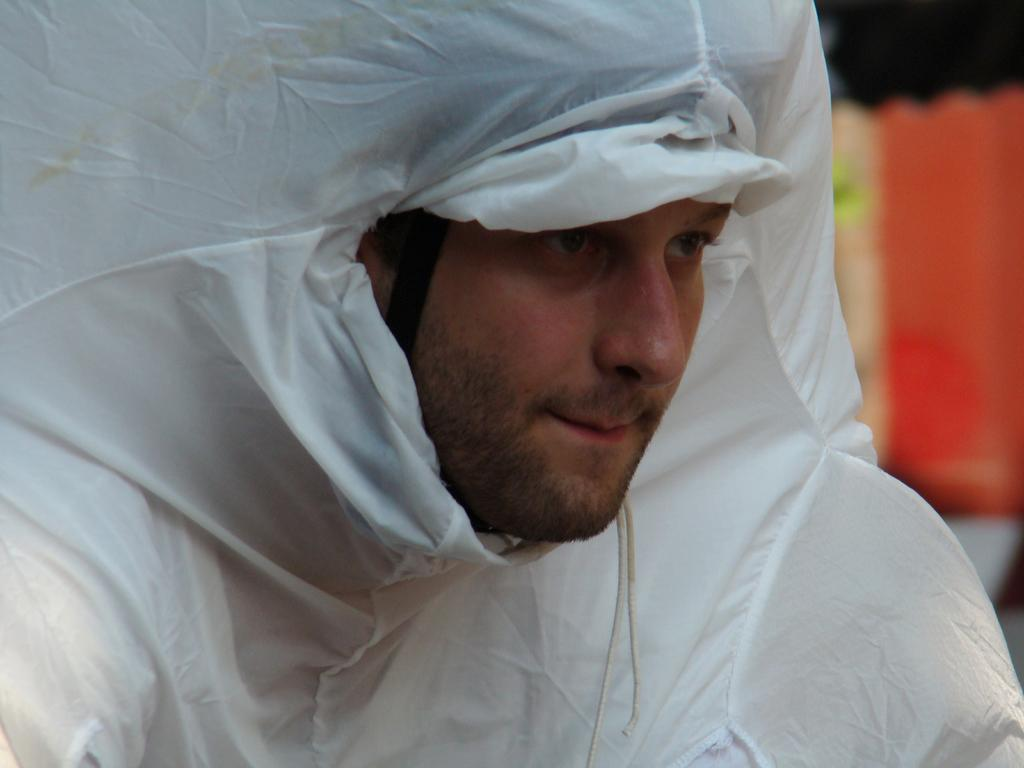Who or what is present in the image? There is a person in the image. What is the person wearing? The person is wearing a raincoat. In which direction is the person looking? The person is looking to the right side. Can you describe the background of the image? The background of the image is blurred. What type of cheese is being rewarded to the person in the image? There is no cheese or reward present in the image. How many bits can be seen in the person's mouth in the image? There are no bits visible in the person's mouth in the image. 